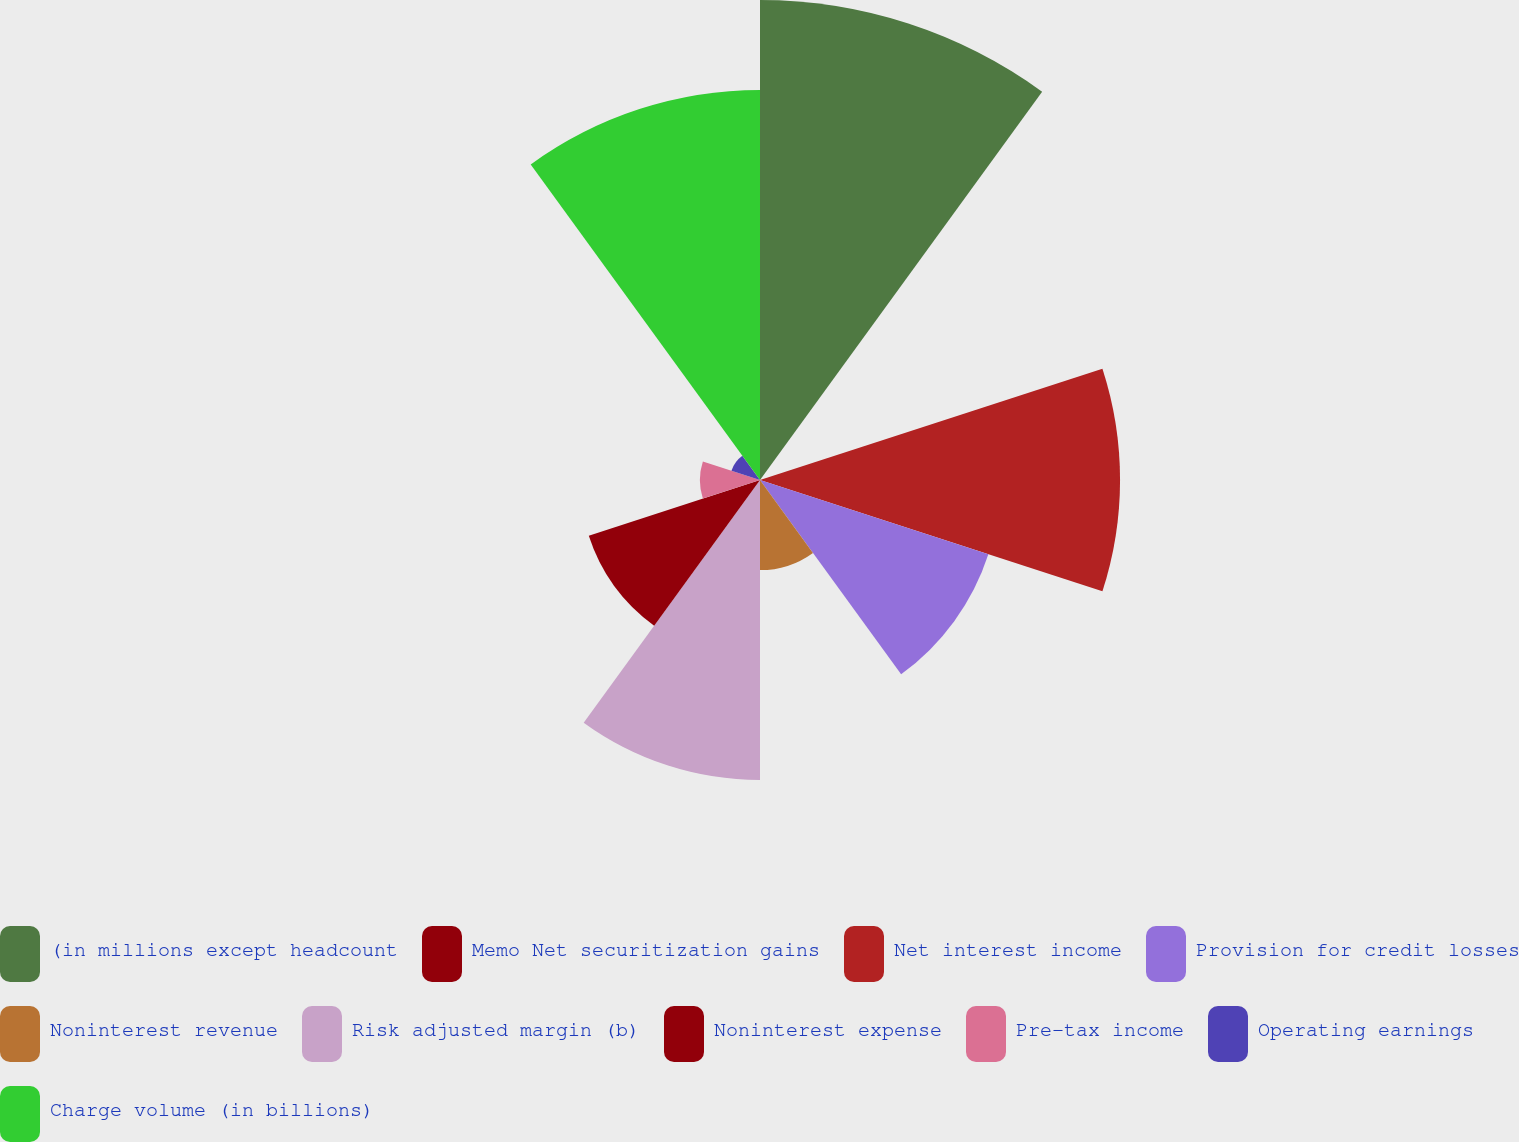Convert chart to OTSL. <chart><loc_0><loc_0><loc_500><loc_500><pie_chart><fcel>(in millions except headcount<fcel>Memo Net securitization gains<fcel>Net interest income<fcel>Provision for credit losses<fcel>Noninterest revenue<fcel>Risk adjusted margin (b)<fcel>Noninterest expense<fcel>Pre-tax income<fcel>Operating earnings<fcel>Charge volume (in billions)<nl><fcel>22.53%<fcel>0.0%<fcel>16.9%<fcel>11.27%<fcel>4.23%<fcel>14.08%<fcel>8.45%<fcel>2.82%<fcel>1.41%<fcel>18.31%<nl></chart> 